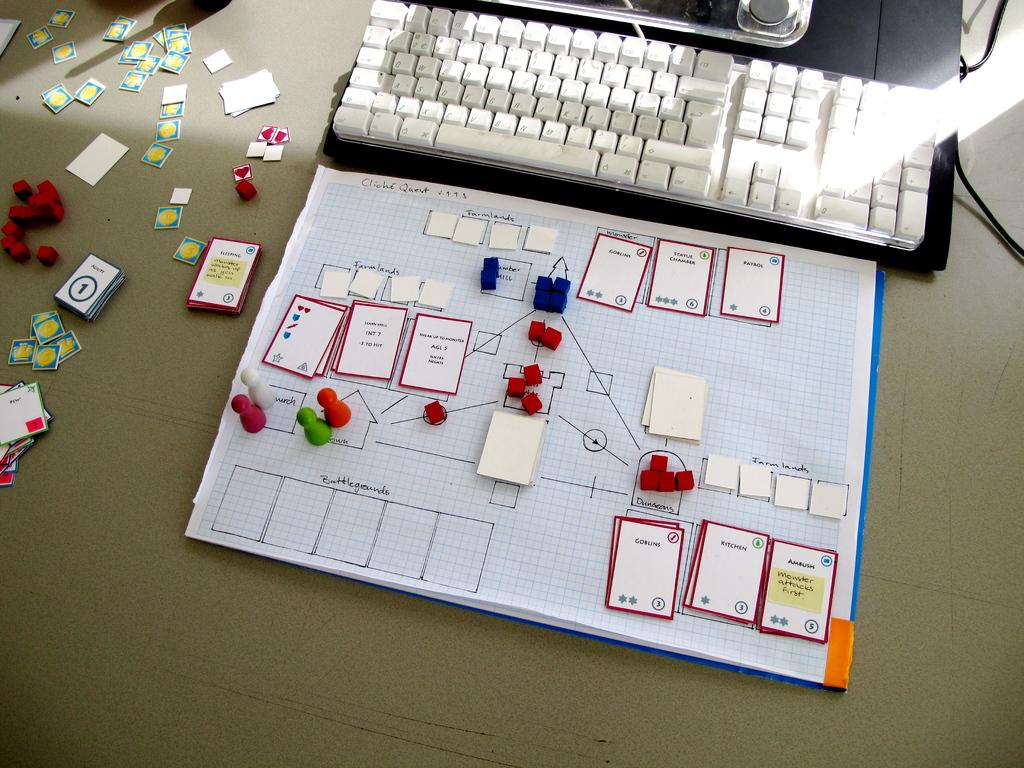<image>
Relay a brief, clear account of the picture shown. A hand drawn game board with game pieces and cards, one has goblins on it, is in front of a keyboard. 